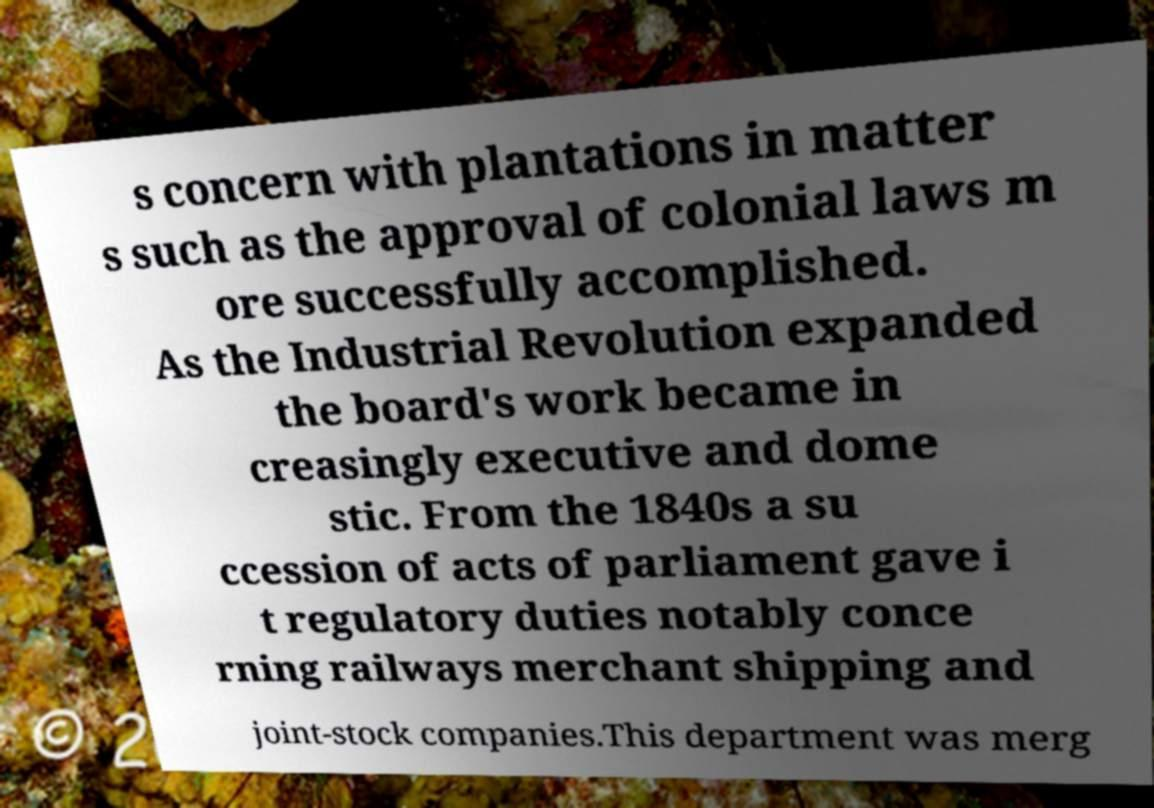There's text embedded in this image that I need extracted. Can you transcribe it verbatim? s concern with plantations in matter s such as the approval of colonial laws m ore successfully accomplished. As the Industrial Revolution expanded the board's work became in creasingly executive and dome stic. From the 1840s a su ccession of acts of parliament gave i t regulatory duties notably conce rning railways merchant shipping and joint-stock companies.This department was merg 